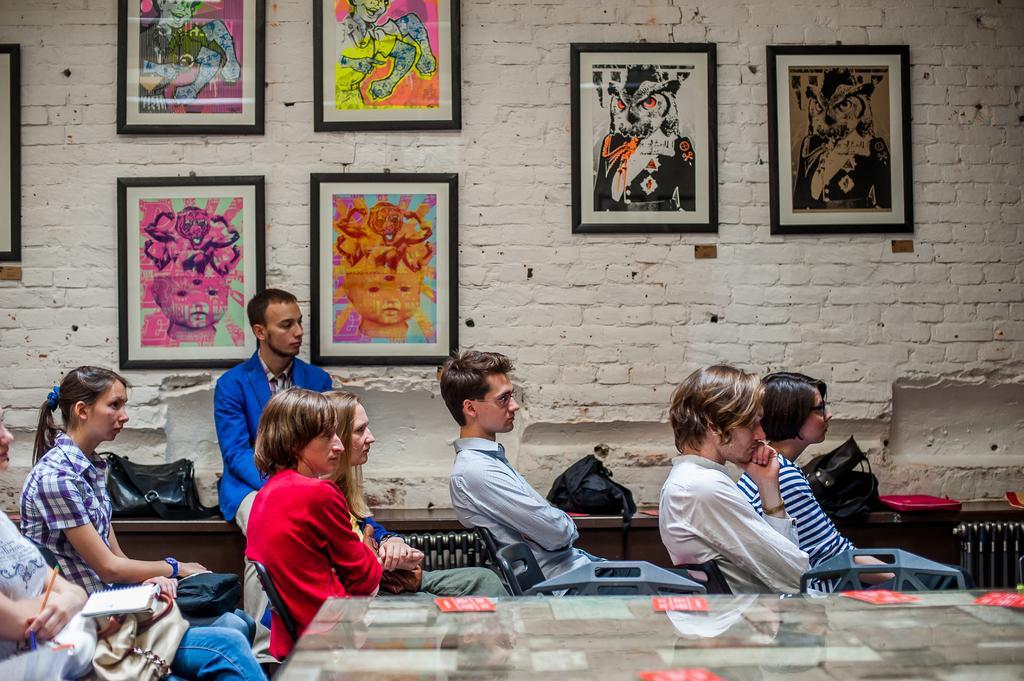Please provide a concise description of this image. There are few people sitting and listening to something in this room. In the background there are few pictures and is painted. There is a bag on this table. There is another table in this room. There are few papers on this table. A lady is wearing blue and white shirt. She is having a watch on her hand. This lady is having a pencil. She is having a bag on her lap and holding a book also. 